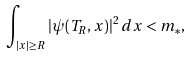Convert formula to latex. <formula><loc_0><loc_0><loc_500><loc_500>\int _ { | x | \geq R } | \psi ( T _ { R } , x ) | ^ { 2 } \, d x < m _ { * } ,</formula> 